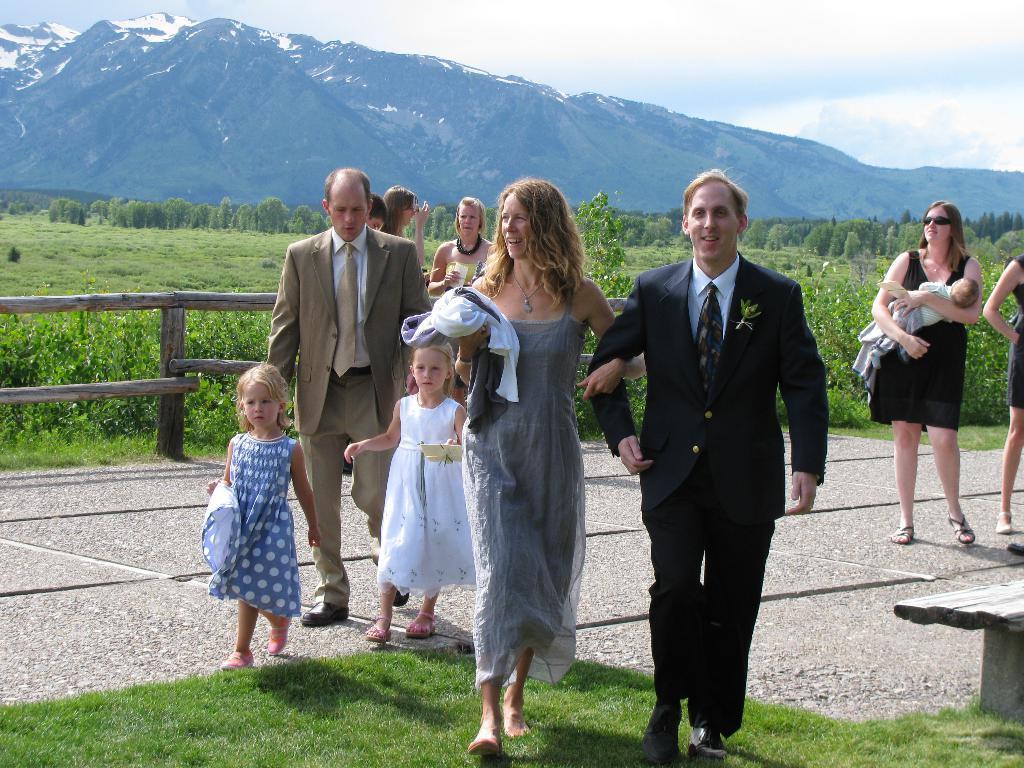How would you summarize this image in a sentence or two? In the picture we can see a road on it, we can see a man and a woman are walking together and coming and man is in blazer, tie and shirt and behind them, we can see two girl children are also walking and one woman is holding a baby and behind them, we can see a railing and behind it we can see a grass surface with plants and far away from it we can see trees, mountains with snow on it and a sky with clouds. 